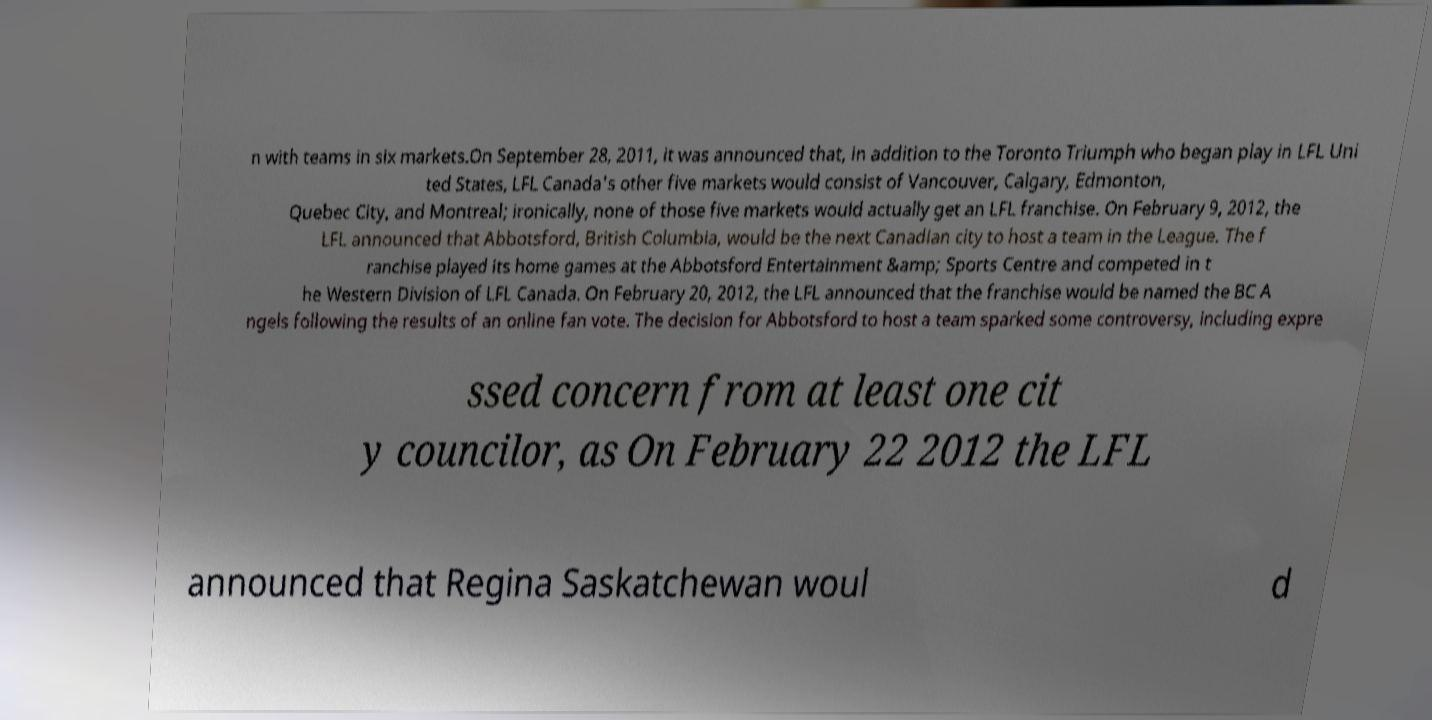Can you accurately transcribe the text from the provided image for me? n with teams in six markets.On September 28, 2011, it was announced that, in addition to the Toronto Triumph who began play in LFL Uni ted States, LFL Canada's other five markets would consist of Vancouver, Calgary, Edmonton, Quebec City, and Montreal; ironically, none of those five markets would actually get an LFL franchise. On February 9, 2012, the LFL announced that Abbotsford, British Columbia, would be the next Canadian city to host a team in the League. The f ranchise played its home games at the Abbotsford Entertainment &amp; Sports Centre and competed in t he Western Division of LFL Canada. On February 20, 2012, the LFL announced that the franchise would be named the BC A ngels following the results of an online fan vote. The decision for Abbotsford to host a team sparked some controversy, including expre ssed concern from at least one cit y councilor, as On February 22 2012 the LFL announced that Regina Saskatchewan woul d 